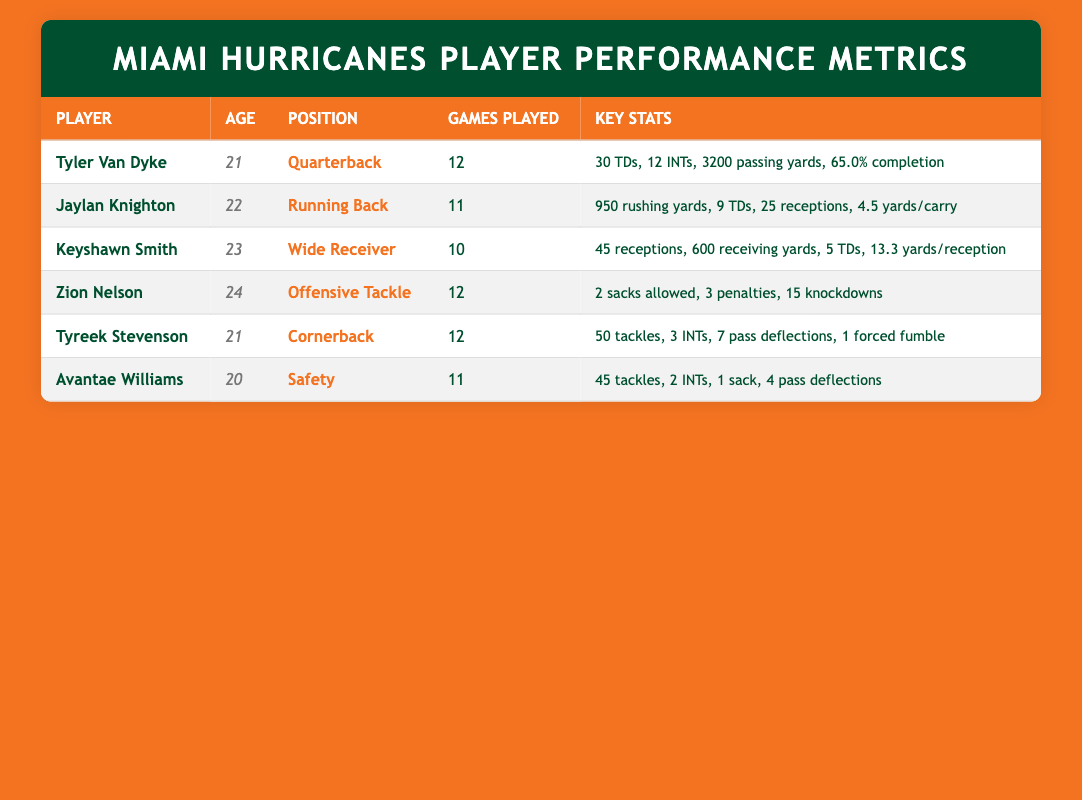What is the age of Tyler Van Dyke? Tyler Van Dyke is listed in the table with the age column showing the value 21. Therefore, he is 21 years old.
Answer: 21 How many touchdowns did Jaylan Knighton score? In the table, Jaylan Knighton's key stats show that he scored 9 touchdowns. This is directly taken from the touchdowns column for Jaylan Knighton.
Answer: 9 Which player has the highest number of passing yards? The table indicates that Tyler Van Dyke has 3200 passing yards, which is the only passing yard statistic listed. No other player has a passing yards statistic, meaning Tyler Van Dyke has the highest.
Answer: Tyler Van Dyke What is the total number of games played by all players listed? To find the total games played, add the games played by each player: 12 (Tyler Van Dyke) + 11 (Jaylan Knighton) + 10 (Keyshawn Smith) + 12 (Zion Nelson) + 12 (Tyreek Stevenson) + 11 (Avantae Williams) = 78. Therefore, the total games played is 78.
Answer: 78 Is Avantae Williams older than Keyshawn Smith? Avantae Williams is listed as 20 years old, while Keyshawn Smith is 23 years old. Therefore, since 20 is less than 23, Avantae Williams is not older than Keyshawn Smith.
Answer: No What is the difference in touchdowns scored between Tyler Van Dyke and Keyshawn Smith? Tyler Van Dyke scored 30 touchdowns while Keyshawn Smith scored 5 touchdowns. The difference is calculated as 30 - 5 = 25. Thus, the difference in touchdowns scored is 25.
Answer: 25 Which player has the highest completion percentage? The only player with a completion percentage listed is Tyler Van Dyke, who has a completion percentage of 65.0%. Therefore, he holds the highest completion percentage among the players in the table.
Answer: Tyler Van Dyke How many total tackles were made by Tyreek Stevenson and Avantae Williams combined? Tyreek Stevenson recorded 50 tackles and Avantae Williams recorded 45 tackles. Adding these gives 50 + 45 = 95. Thus, the total combined tackles are 95.
Answer: 95 Does Zion Nelson have more penalties than Avantae Williams has interceptions? Zion Nelson has 3 penalties, and Avantae Williams has 2 interceptions. Since 3 is greater than 2, Zion Nelson indeed has more penalties than Avantae Williams has interceptions.
Answer: Yes 